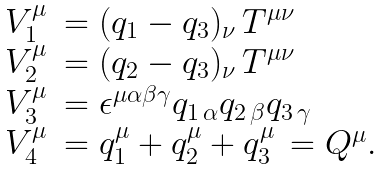<formula> <loc_0><loc_0><loc_500><loc_500>\begin{array} { l l } V _ { 1 } ^ { \mu } & = ( q _ { 1 } - q _ { 3 } ) _ { \nu } \, T ^ { \mu \nu } \\ V _ { 2 } ^ { \mu } & = ( q _ { 2 } - q _ { 3 } ) _ { \nu } \, T ^ { \mu \nu } \\ V _ { 3 } ^ { \mu } & = \epsilon ^ { \mu \alpha \beta \gamma } q _ { 1 \, \alpha } q _ { 2 \, \beta } q _ { 3 \, \gamma } \\ V _ { 4 } ^ { \mu } & = q _ { 1 } ^ { \mu } + q _ { 2 } ^ { \mu } + q _ { 3 } ^ { \mu } \, = Q ^ { \mu } . \end{array}</formula> 